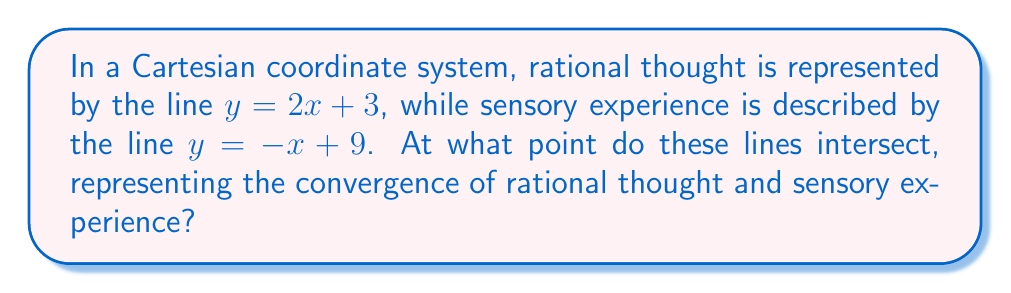Teach me how to tackle this problem. To find the point of intersection, we need to solve the system of linear equations:

$$\begin{cases}
y = 2x + 3 \\
y = -x + 9
\end{cases}$$

Step 1: Set the equations equal to each other since they intersect at a point where y-values are the same.
$2x + 3 = -x + 9$

Step 2: Solve for x by combining like terms and isolating x.
$2x + x = 9 - 3$
$3x = 6$
$x = 2$

Step 3: Substitute x = 2 into either of the original equations to find y. Let's use the first equation:
$y = 2(2) + 3$
$y = 4 + 3 = 7$

Therefore, the point of intersection is (2, 7).

[asy]
import graph;
size(200);
xaxis("x", -1, 5, Arrow);
yaxis("y", 0, 10, Arrow);
draw((0,3)--(3,9), blue, Legend("Rational thought"));
draw((0,9)--(5,4), red, Legend("Sensory experience"));
dot((2,7), black);
label("(2, 7)", (2,7), NE);
[/asy]
Answer: (2, 7) 